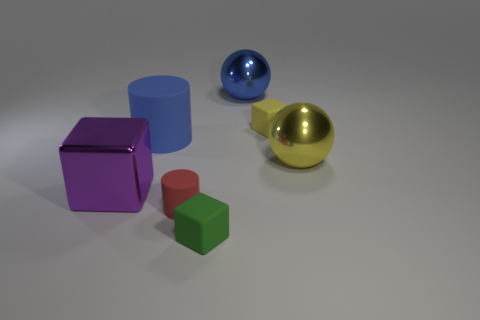How many matte objects are small yellow objects or blue objects?
Ensure brevity in your answer.  2. There is a large object to the right of the small matte cube that is behind the purple metal thing; is there a matte object in front of it?
Your answer should be very brief. Yes. There is a blue cylinder that is made of the same material as the red cylinder; what is its size?
Make the answer very short. Large. There is a red object; are there any large purple metal blocks left of it?
Provide a short and direct response. Yes. Is there a metal sphere that is in front of the sphere that is to the left of the yellow metal thing?
Your response must be concise. Yes. Is the size of the shiny ball that is left of the large yellow shiny ball the same as the rubber cylinder that is behind the purple metallic cube?
Your answer should be very brief. Yes. What number of large things are red objects or blue objects?
Your answer should be very brief. 2. What material is the blue object in front of the blue object that is behind the large rubber thing?
Keep it short and to the point. Rubber. What is the shape of the metallic object that is the same color as the big rubber cylinder?
Provide a succinct answer. Sphere. Is there a large ball made of the same material as the purple cube?
Your answer should be very brief. Yes. 